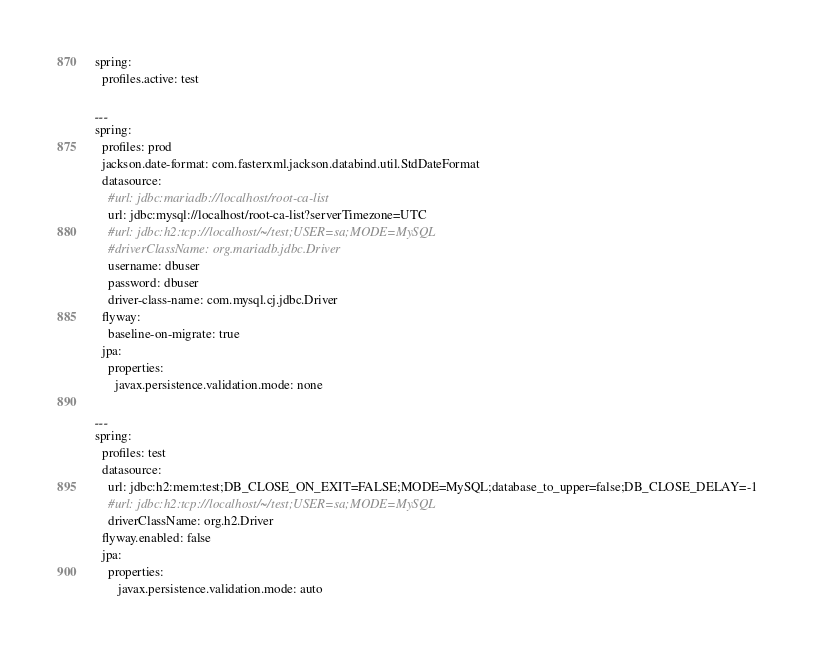Convert code to text. <code><loc_0><loc_0><loc_500><loc_500><_YAML_>spring:
  profiles.active: test

---
spring:
  profiles: prod
  jackson.date-format: com.fasterxml.jackson.databind.util.StdDateFormat
  datasource:
    #url: jdbc:mariadb://localhost/root-ca-list
    url: jdbc:mysql://localhost/root-ca-list?serverTimezone=UTC
    #url: jdbc:h2:tcp://localhost/~/test;USER=sa;MODE=MySQL
    #driverClassName: org.mariadb.jdbc.Driver
    username: dbuser
    password: dbuser
    driver-class-name: com.mysql.cj.jdbc.Driver
  flyway:
    baseline-on-migrate: true
  jpa:
    properties:
      javax.persistence.validation.mode: none

---
spring:
  profiles: test
  datasource:
    url: jdbc:h2:mem:test;DB_CLOSE_ON_EXIT=FALSE;MODE=MySQL;database_to_upper=false;DB_CLOSE_DELAY=-1
    #url: jdbc:h2:tcp://localhost/~/test;USER=sa;MODE=MySQL
    driverClassName: org.h2.Driver
  flyway.enabled: false
  jpa:
    properties:
       javax.persistence.validation.mode: auto
</code> 